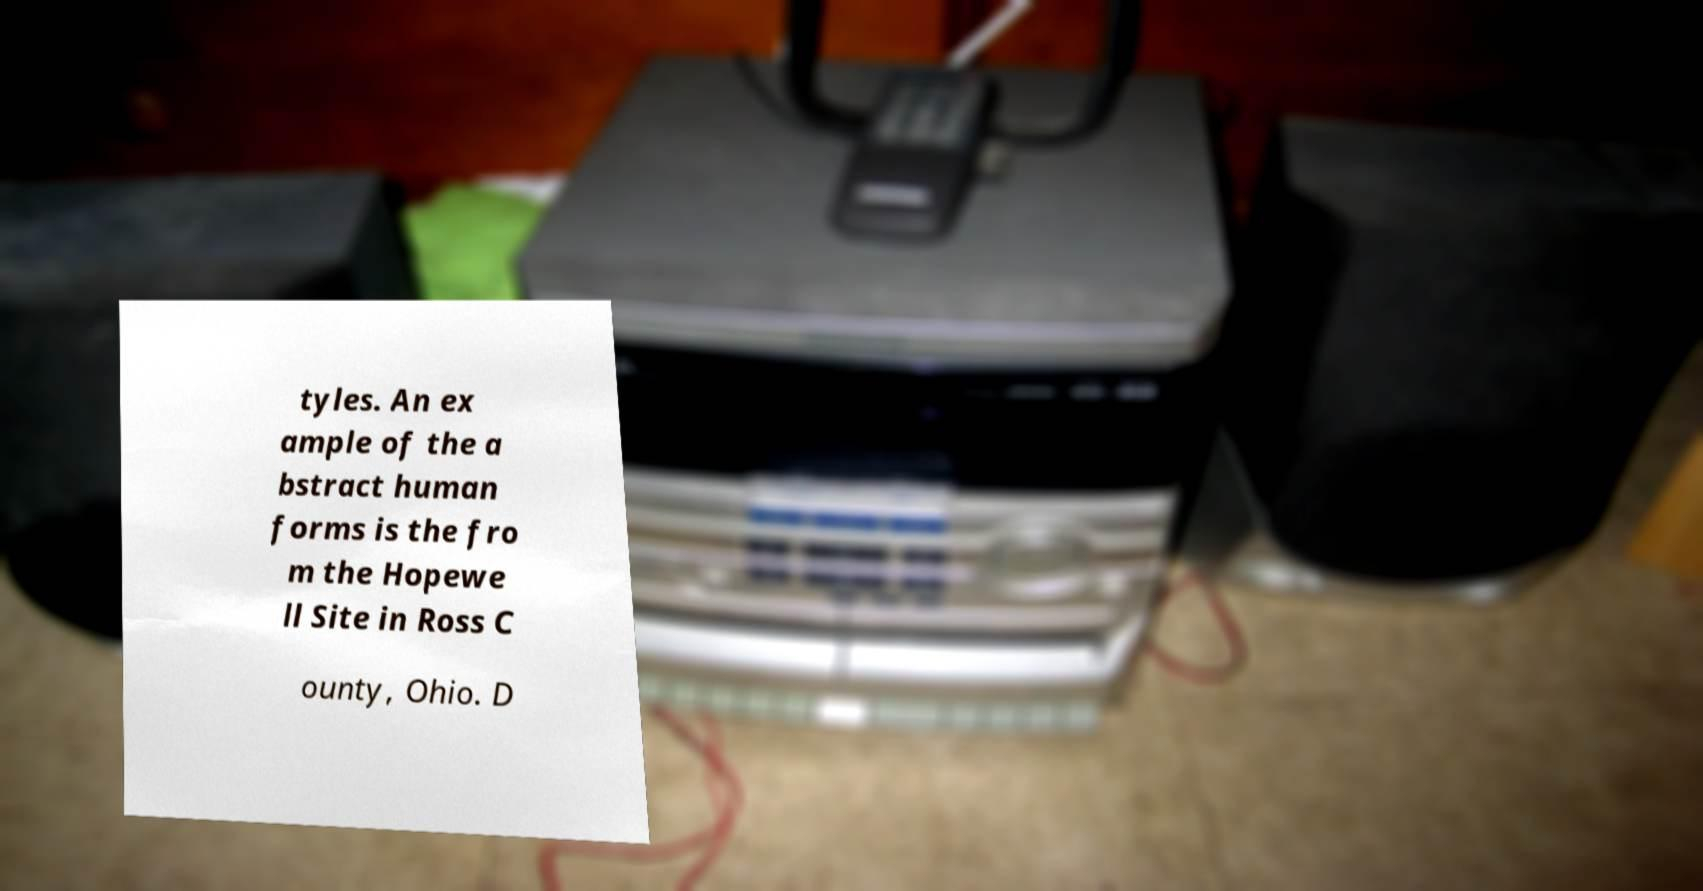Could you assist in decoding the text presented in this image and type it out clearly? tyles. An ex ample of the a bstract human forms is the fro m the Hopewe ll Site in Ross C ounty, Ohio. D 